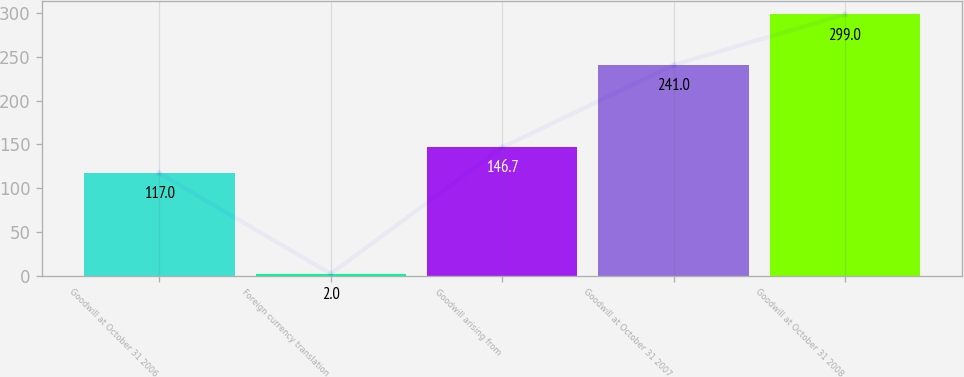Convert chart to OTSL. <chart><loc_0><loc_0><loc_500><loc_500><bar_chart><fcel>Goodwill at October 31 2006<fcel>Foreign currency translation<fcel>Goodwill arising from<fcel>Goodwill at October 31 2007<fcel>Goodwill at October 31 2008<nl><fcel>117<fcel>2<fcel>146.7<fcel>241<fcel>299<nl></chart> 